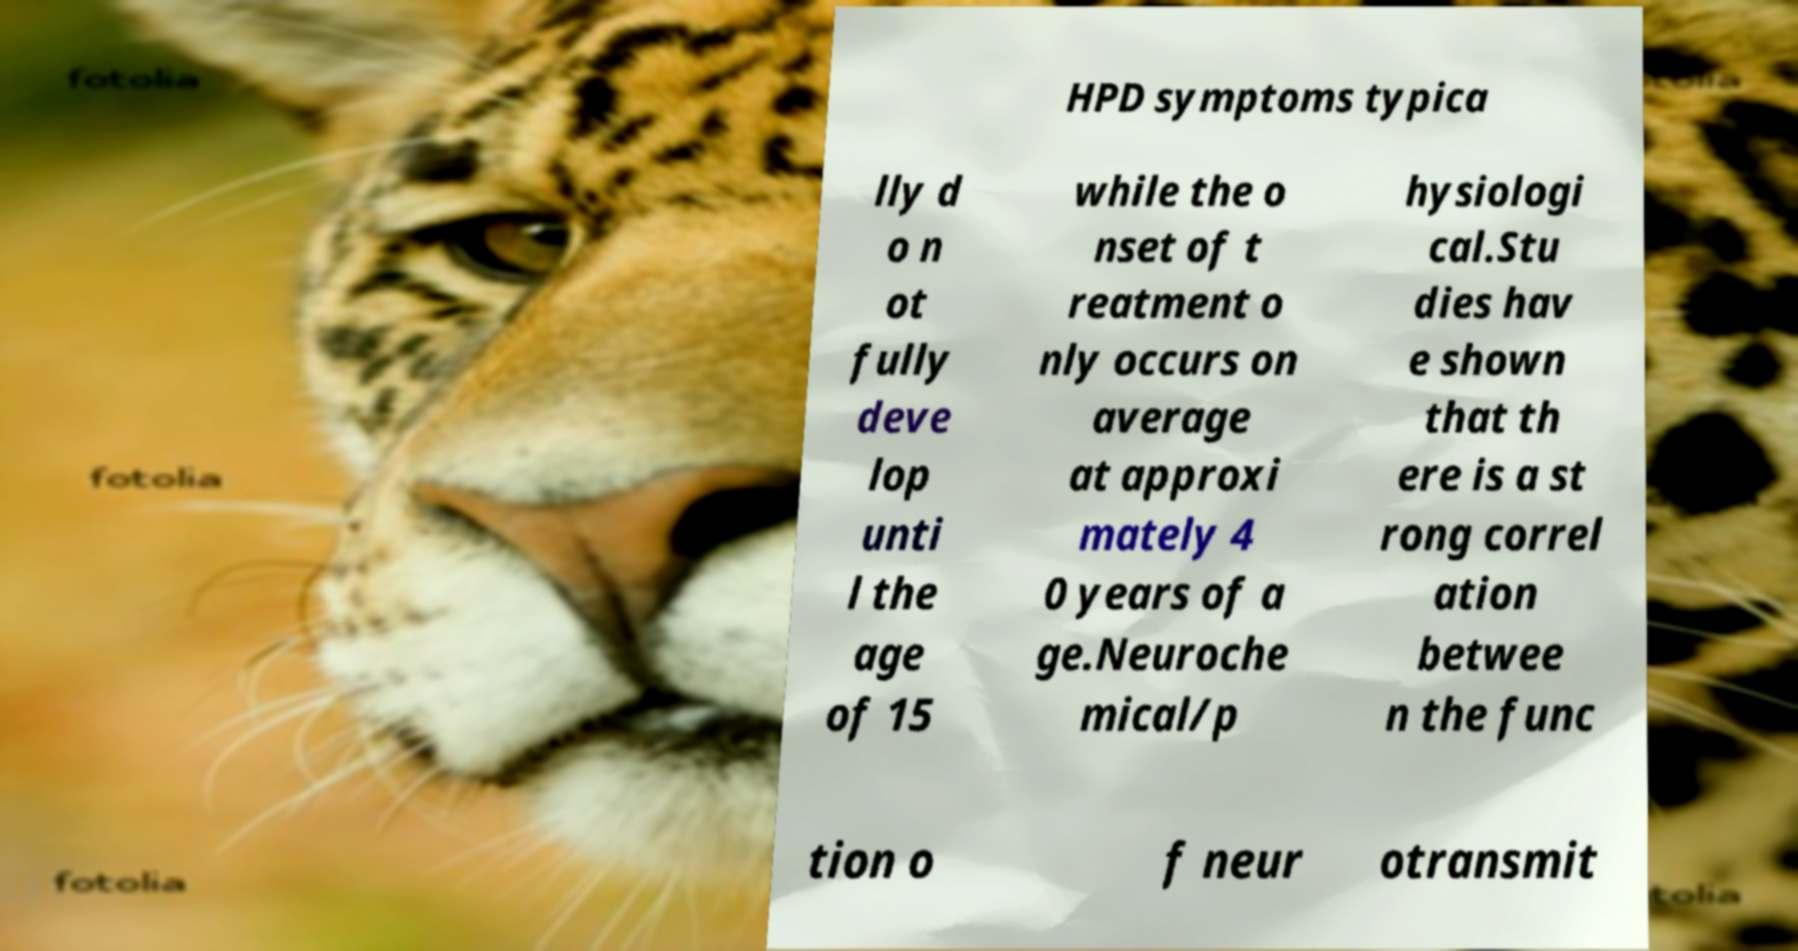For documentation purposes, I need the text within this image transcribed. Could you provide that? HPD symptoms typica lly d o n ot fully deve lop unti l the age of 15 while the o nset of t reatment o nly occurs on average at approxi mately 4 0 years of a ge.Neuroche mical/p hysiologi cal.Stu dies hav e shown that th ere is a st rong correl ation betwee n the func tion o f neur otransmit 